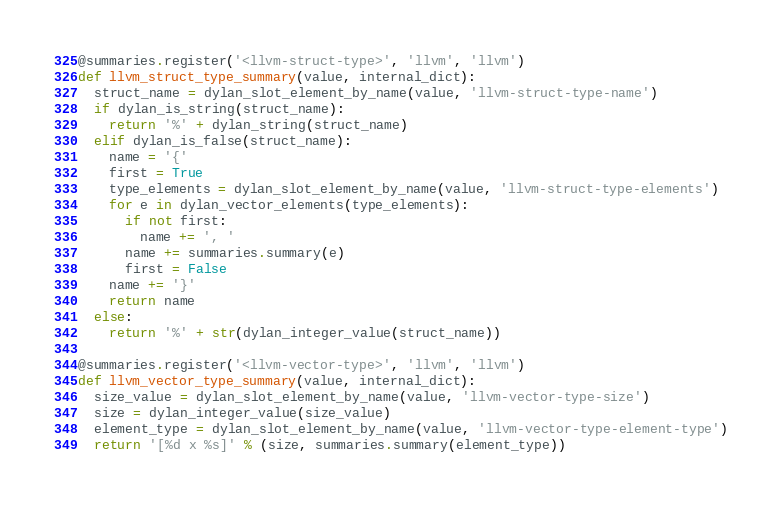<code> <loc_0><loc_0><loc_500><loc_500><_Python_>@summaries.register('<llvm-struct-type>', 'llvm', 'llvm')
def llvm_struct_type_summary(value, internal_dict):
  struct_name = dylan_slot_element_by_name(value, 'llvm-struct-type-name')
  if dylan_is_string(struct_name):
    return '%' + dylan_string(struct_name)
  elif dylan_is_false(struct_name):
    name = '{'
    first = True
    type_elements = dylan_slot_element_by_name(value, 'llvm-struct-type-elements')
    for e in dylan_vector_elements(type_elements):
      if not first:
        name += ', '
      name += summaries.summary(e)
      first = False
    name += '}'
    return name
  else:
    return '%' + str(dylan_integer_value(struct_name))

@summaries.register('<llvm-vector-type>', 'llvm', 'llvm')
def llvm_vector_type_summary(value, internal_dict):
  size_value = dylan_slot_element_by_name(value, 'llvm-vector-type-size')
  size = dylan_integer_value(size_value)
  element_type = dylan_slot_element_by_name(value, 'llvm-vector-type-element-type')
  return '[%d x %s]' % (size, summaries.summary(element_type))
</code> 